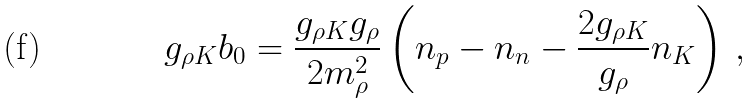<formula> <loc_0><loc_0><loc_500><loc_500>g _ { \rho K } b _ { 0 } = \frac { g _ { \rho K } g _ { \rho } } { 2 m _ { \rho } ^ { 2 } } \left ( n _ { p } - n _ { n } - \frac { 2 g _ { \rho K } } { g _ { \rho } } n _ { K } \right ) \, ,</formula> 